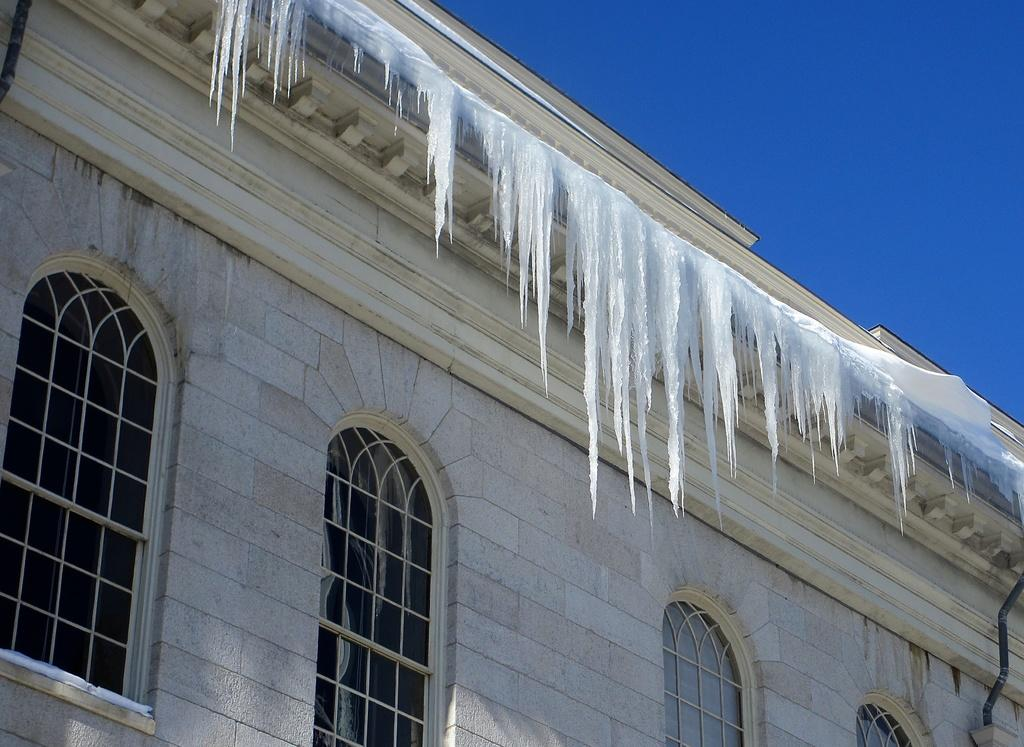What structure is present in the image? There is a building in the image. What architectural feature can be seen on the building? There are windows visible in the image. What type of weather is depicted in the image? There is snow in the image. What color is the sky in the image? The sky is blue in the image. How many chairs are visible in the image? There are no chairs present in the image. What month is it in the image? The month cannot be determined from the image, as there is no specific indication of the time of year. 